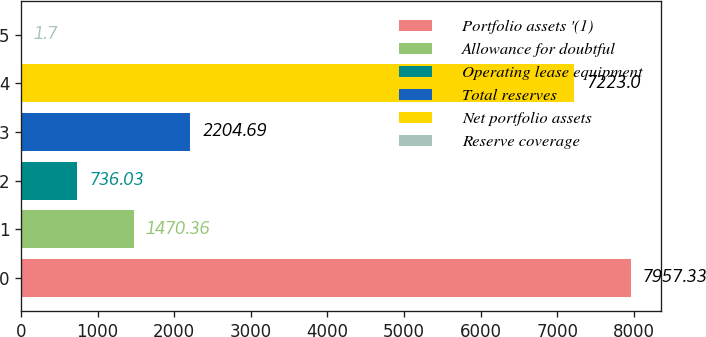Convert chart to OTSL. <chart><loc_0><loc_0><loc_500><loc_500><bar_chart><fcel>Portfolio assets '(1)<fcel>Allowance for doubtful<fcel>Operating lease equipment<fcel>Total reserves<fcel>Net portfolio assets<fcel>Reserve coverage<nl><fcel>7957.33<fcel>1470.36<fcel>736.03<fcel>2204.69<fcel>7223<fcel>1.7<nl></chart> 